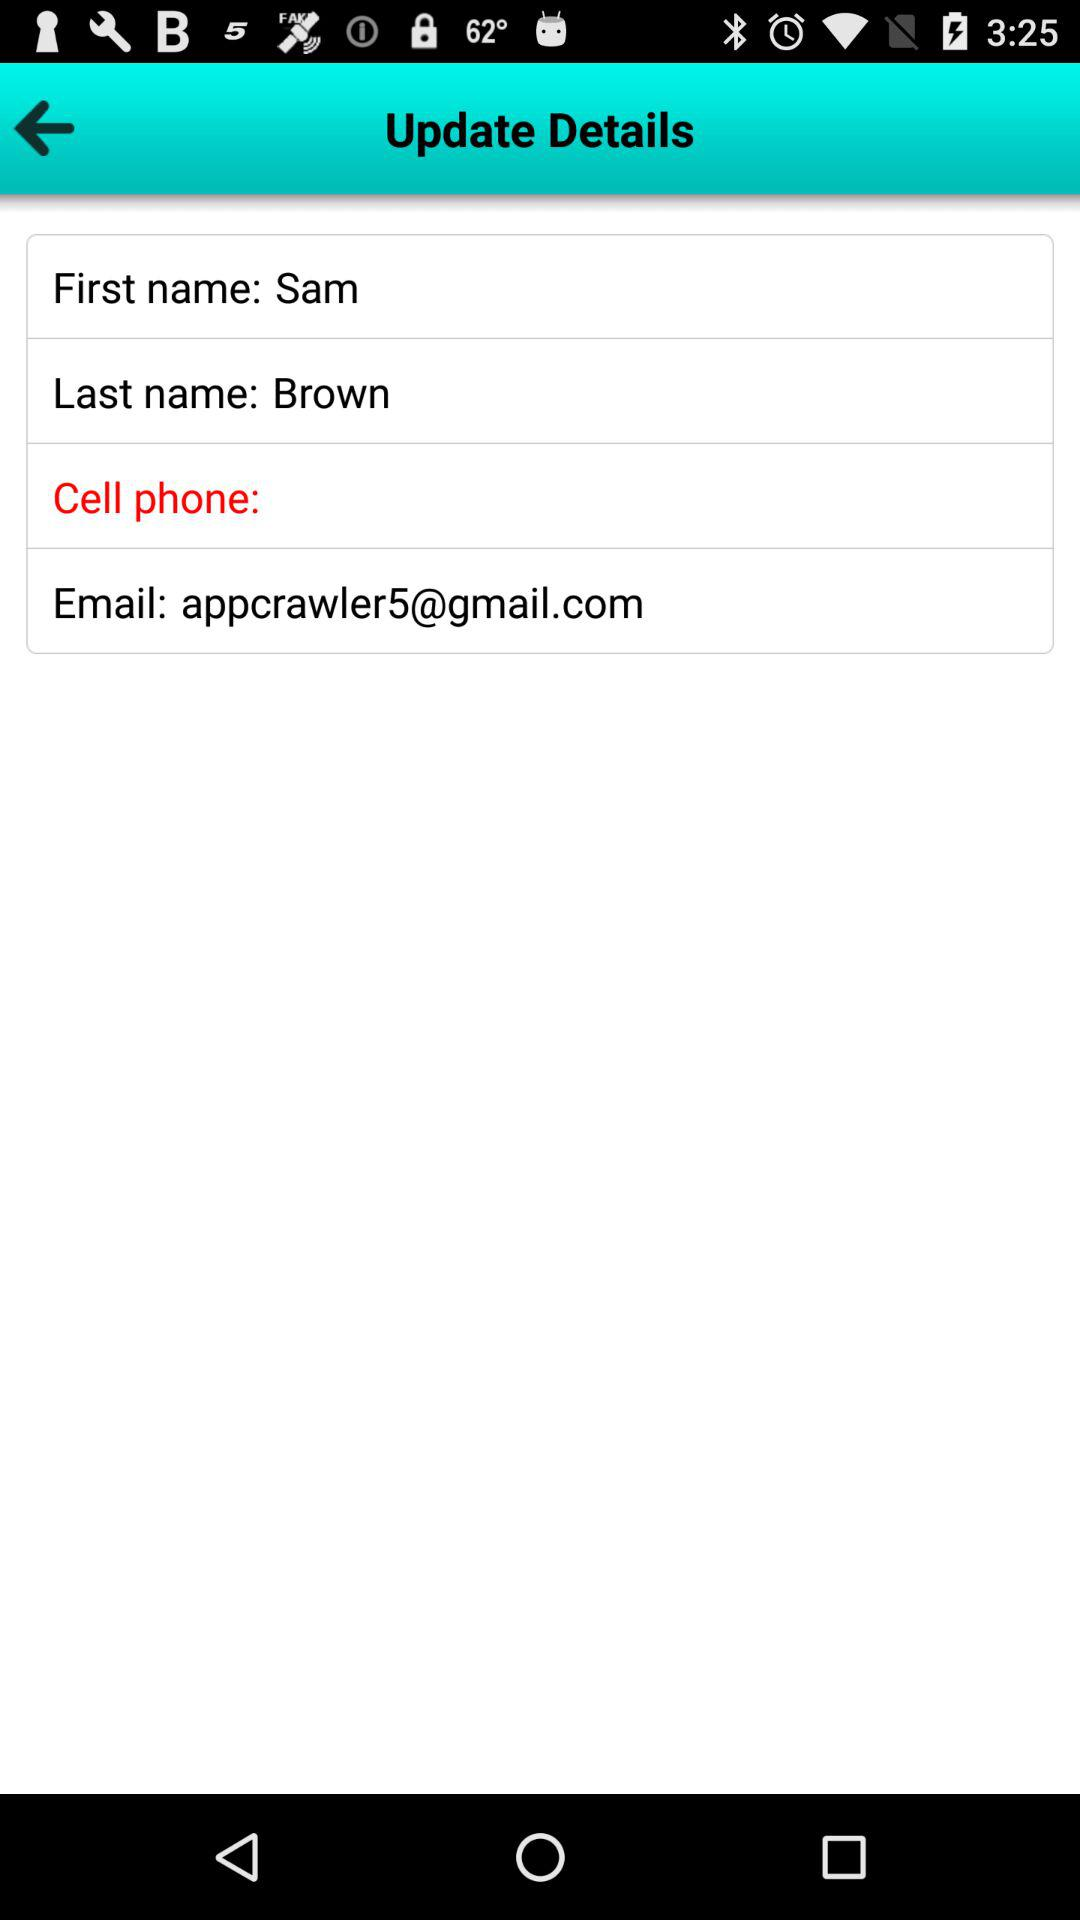What is the last name of the user? The last name of the user is Brown. 